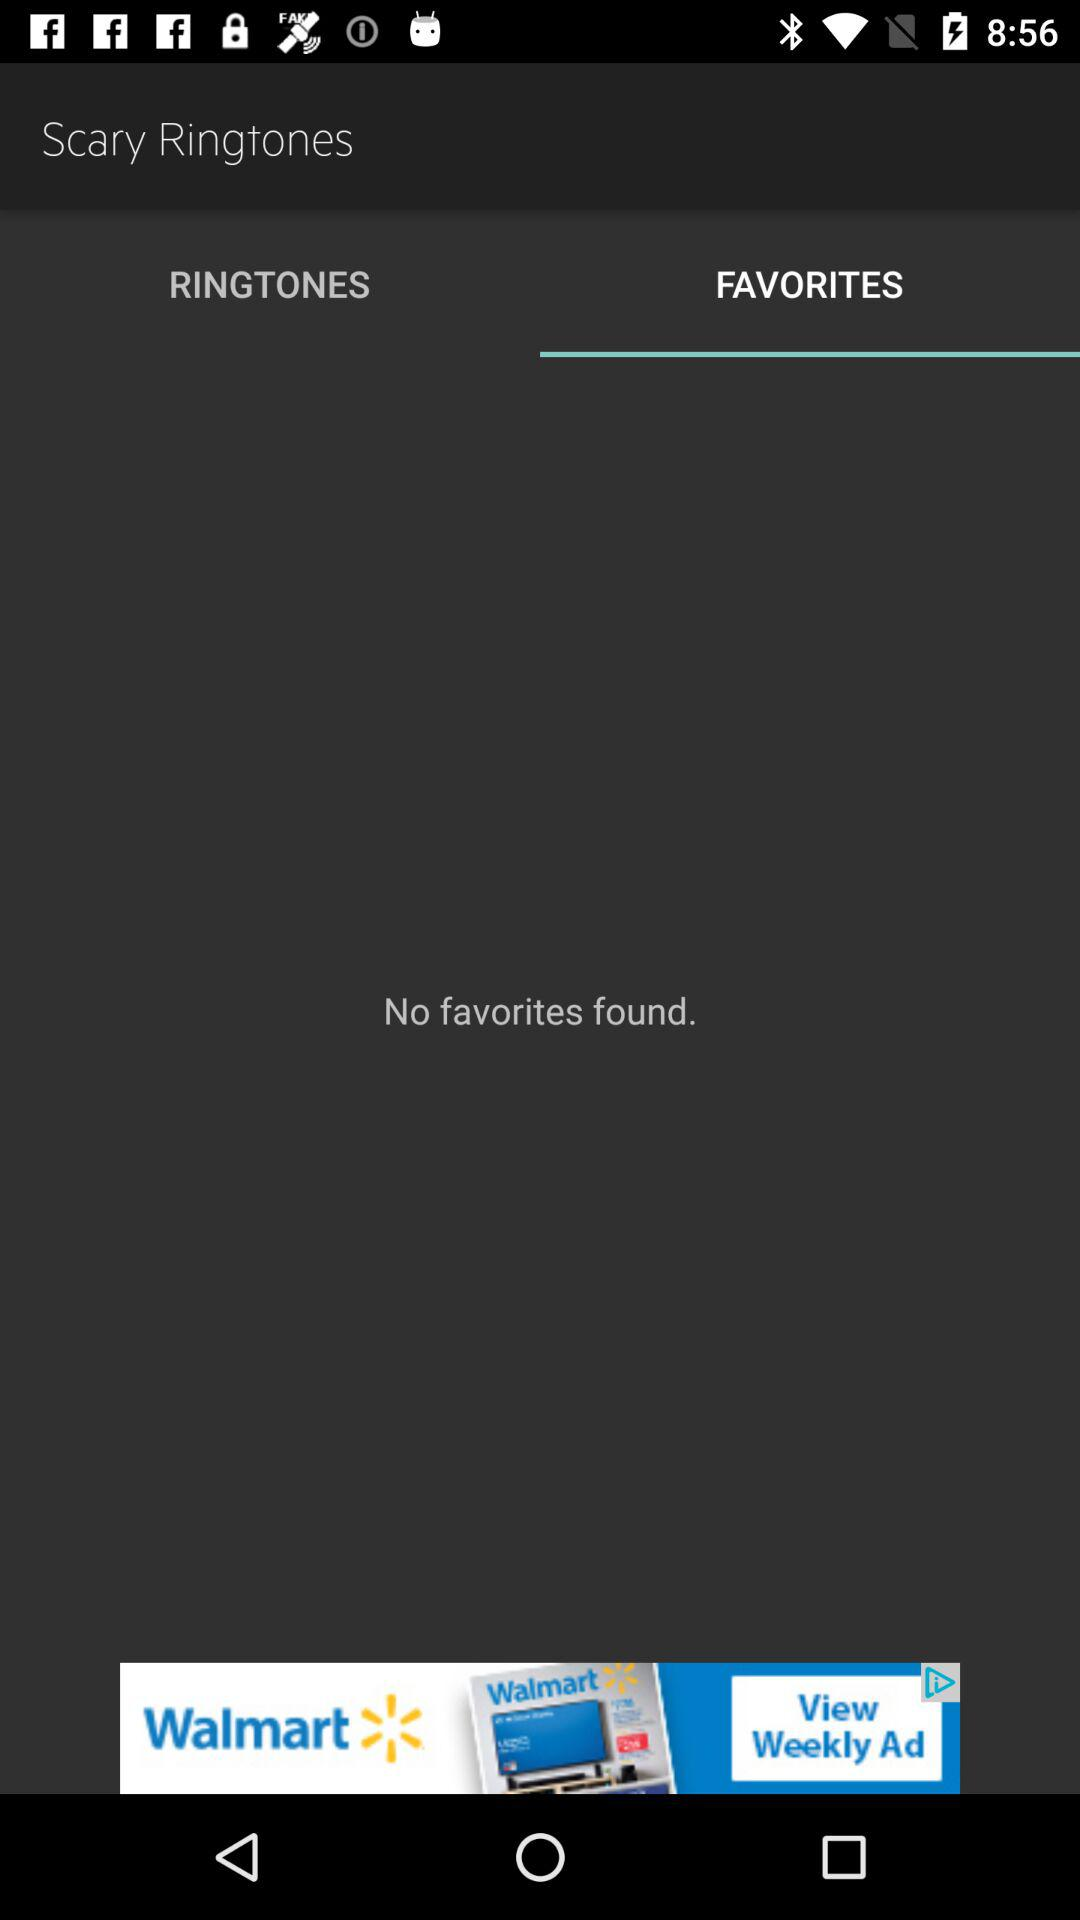Which tab is selected? The selected tab is "FAVORITES". 